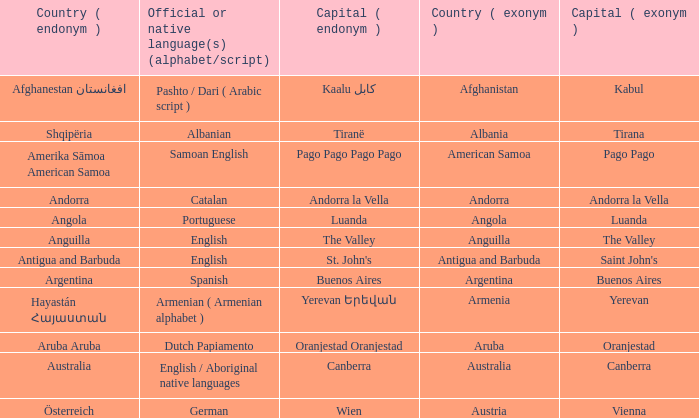What is the English name of the country whose official native language is Dutch Papiamento? Aruba. 